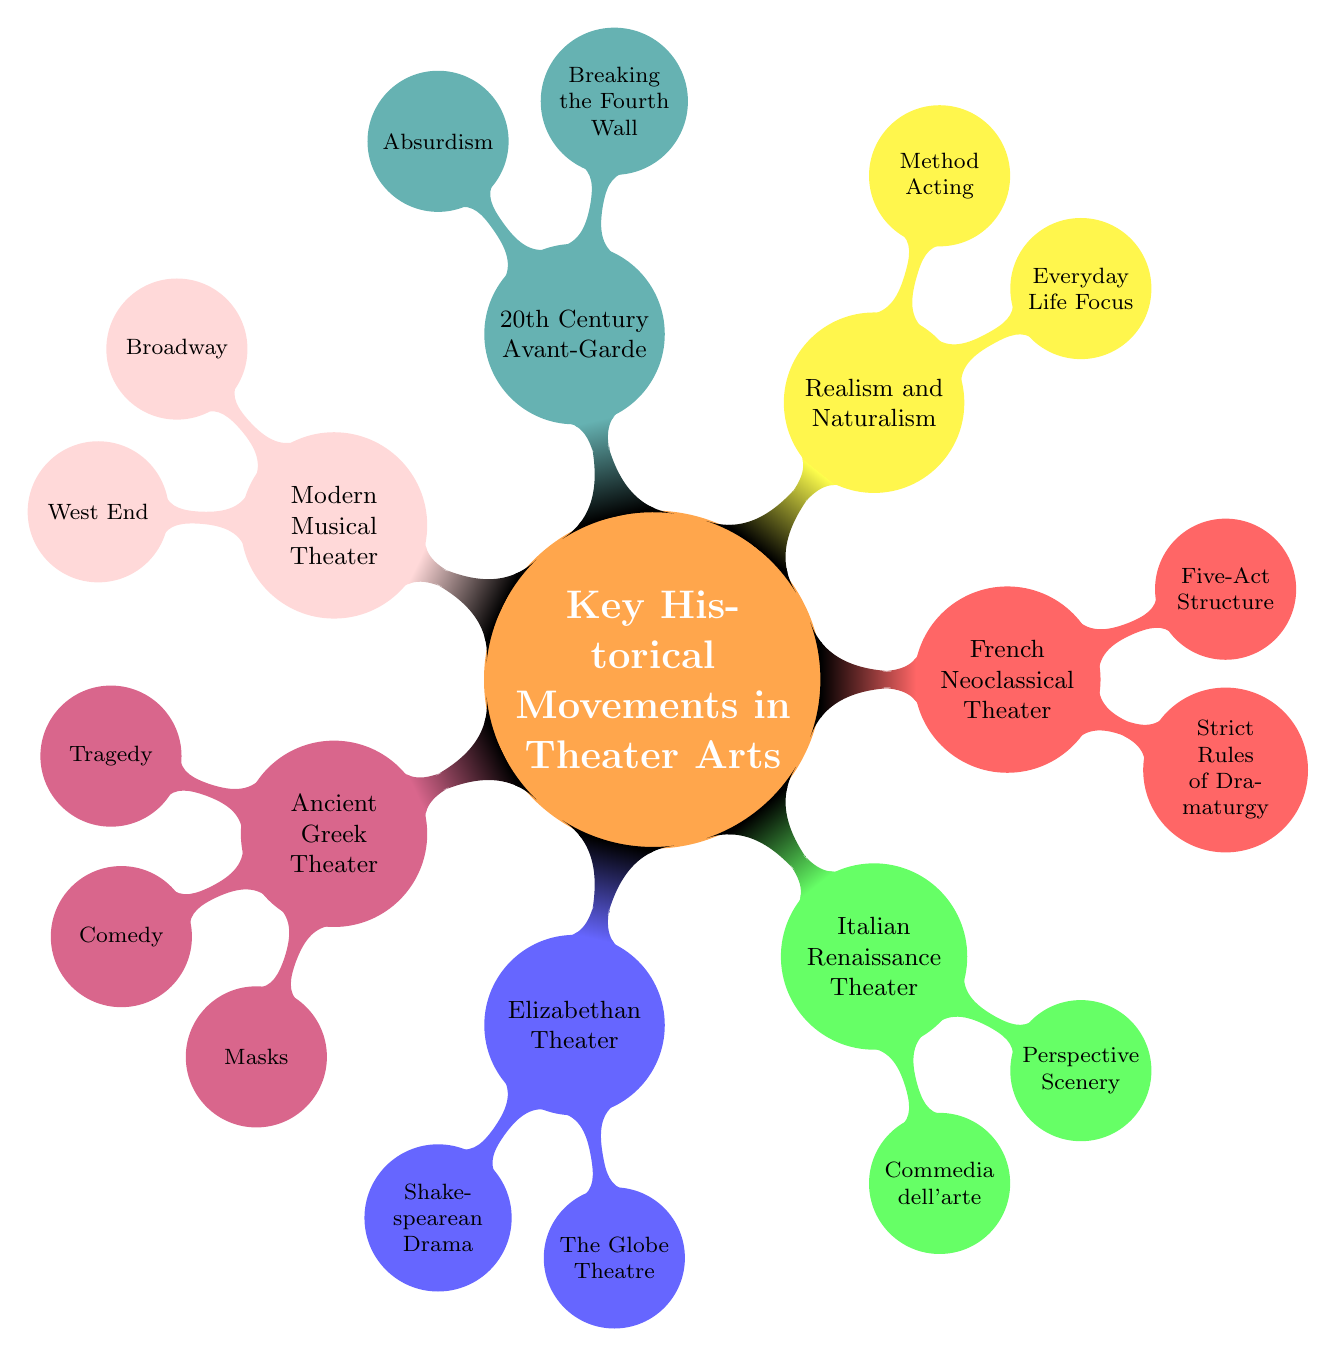What are the key features of Ancient Greek Theater? The diagram shows three key features listed under Ancient Greek Theater: Tragedy, Comedy, and Masks. Therefore, the answer is a combination of these elements.
Answer: Tragedy, Comedy, Masks Who is one of the notable playwrights of French Neoclassical Theater? The diagram indicates that Molière and Jean Racine are both notable playwrights under French Neoclassical Theater. Thus, selecting one of them leads to this answer.
Answer: Molière What movement is known for the integration of music, dance, and dialogue? The Modern Musical Theater node specifies this as one of its key features, indicating that this movement is named for this characteristic.
Answer: Modern Musical Theater How many key features are listed under Realism and Naturalism? Under the Realism and Naturalism section, there are two features mentioned: Everyday Life Focus and Method Acting. Counting these gives the total number.
Answer: 2 Which theater movement includes the concept of Absurdism? The 20th Century Avant-Garde and Experimental Theater section specifically lists Absurdism as one of its key features and answers the question regarding which movement it belongs to.
Answer: 20th Century Avant-Garde and Experimental Theater What is a notable figure associated with Italian Renaissance Theater? The diagram points to Niccolò Machiavelli and Carlo Goldoni as notable figures in the Italian Renaissance Theater section. Since either of these names qualifies, I can select one.
Answer: Niccolò Machiavelli How many child nodes are associated with Elizabethan Theater? The Elizabethan Theater section has three child nodes detailing Shakespearean Drama, The Globe Theatre, and the Use of Soliloquy, totaling the count for this part of the diagram.
Answer: 2 Which theatrical movement emphasizes Breaking the Fourth Wall? The diagram specifically links Breaking the Fourth Wall to the 20th Century Avant-Garde and Experimental Theater, which directly answers the question.
Answer: 20th Century Avant-Garde and Experimental Theater 